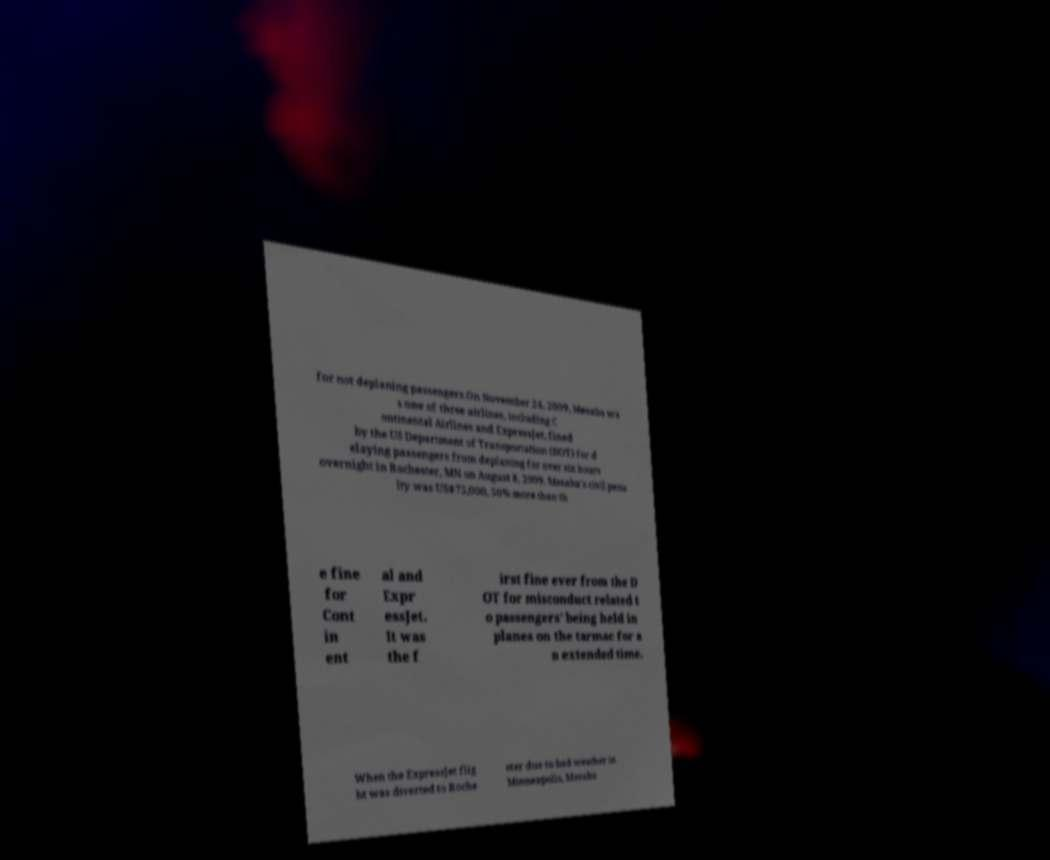Can you accurately transcribe the text from the provided image for me? for not deplaning passengers.On November 24, 2009, Mesaba wa s one of three airlines, including C ontinental Airlines and ExpressJet, fined by the US Department of Transportation (DOT) for d elaying passengers from deplaning for over six hours overnight in Rochester, MN on August 8, 2009. Mesaba's civil pena lty was US$75,000, 50% more than th e fine for Cont in ent al and Expr essJet. It was the f irst fine ever from the D OT for misconduct related t o passengers' being held in planes on the tarmac for a n extended time. When the ExpressJet flig ht was diverted to Roche ster due to bad weather in Minneapolis, Mesaba 